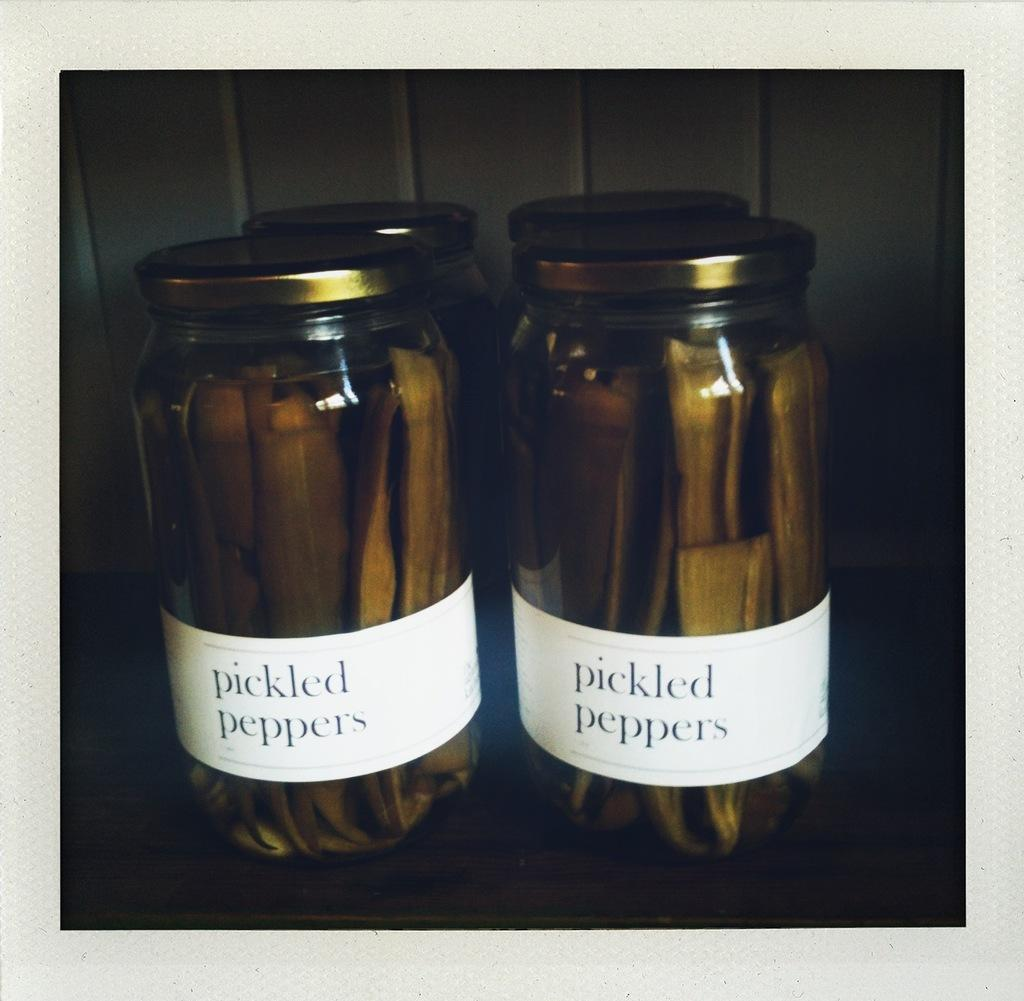<image>
Create a compact narrative representing the image presented. four jars of pickled peppers are sitting on a table 